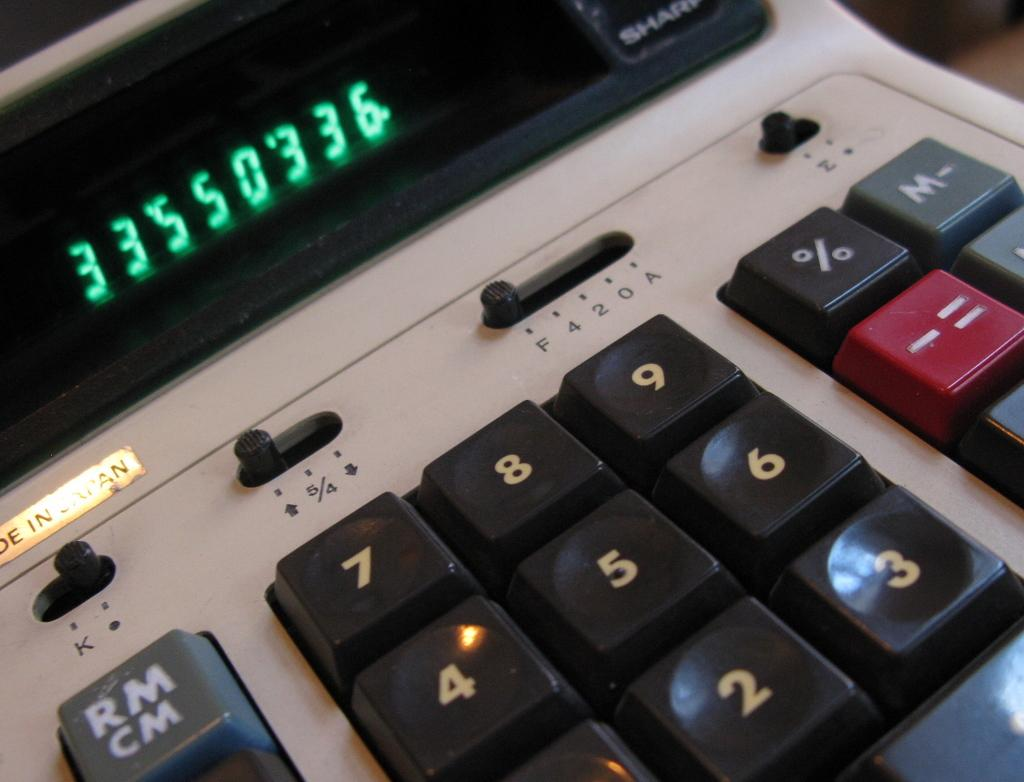<image>
Write a terse but informative summary of the picture. A large calculator with the number 33,550,336 on it in green writing. 